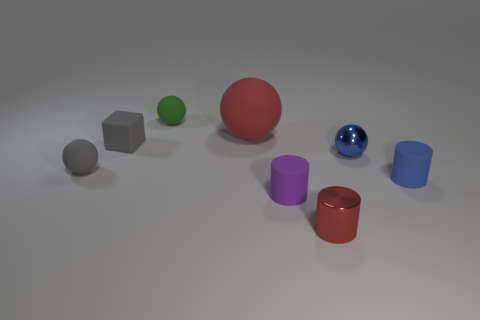How many things are either blue metal spheres or green matte things? In the image provided, there is a total of three items that fit the description: one blue metal sphere and two green matte objects. The blue metal sphere has a distinctive shiny texture that reflects light, making it stand out as metallic. The green matte objects, on the other hand, have a diffused surface that doesn't shine, indicating their matte property. 